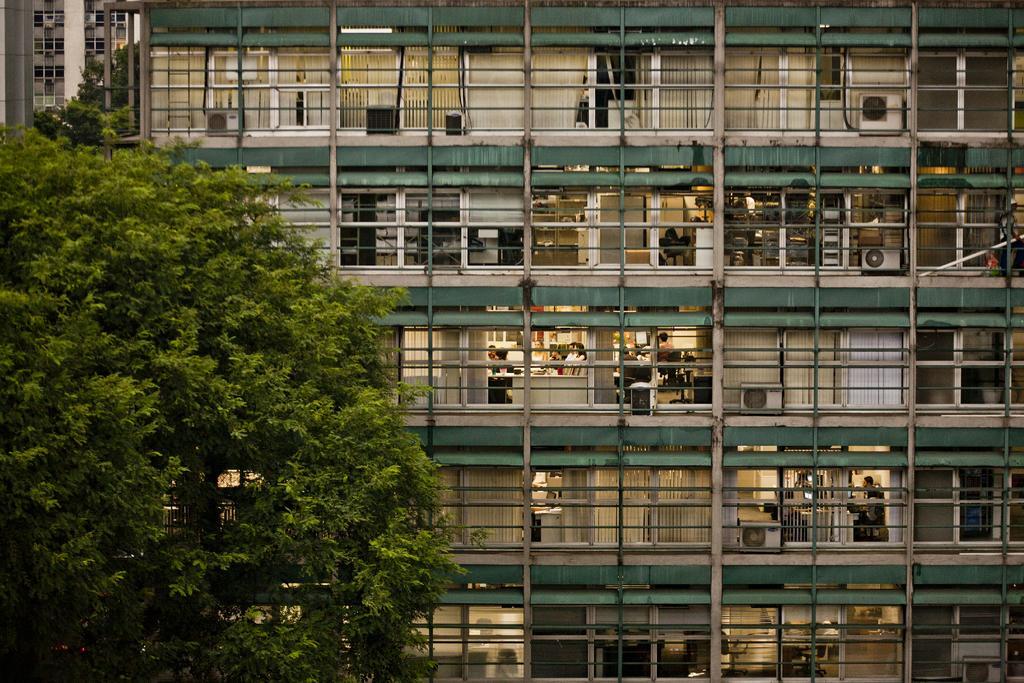Could you give a brief overview of what you see in this image? In this picture I can see the trees on the left side, in the middle there is a building. I can see few people in it. 